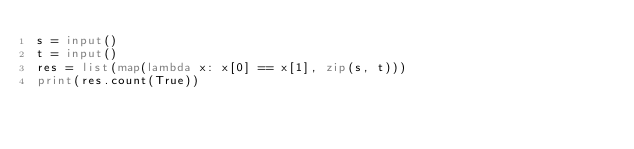<code> <loc_0><loc_0><loc_500><loc_500><_Python_>s = input()
t = input()
res = list(map(lambda x: x[0] == x[1], zip(s, t)))
print(res.count(True))</code> 